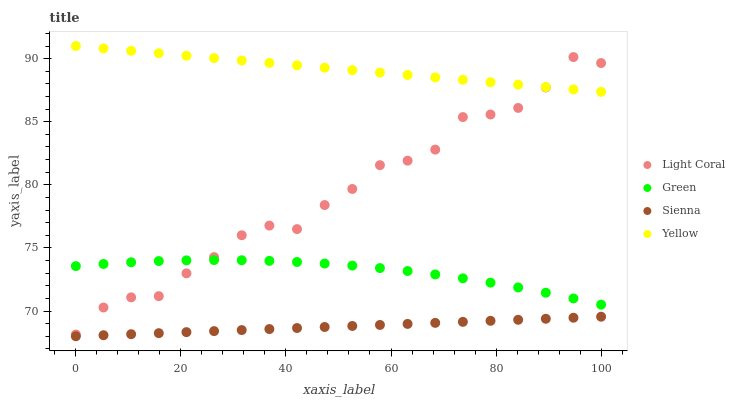Does Sienna have the minimum area under the curve?
Answer yes or no. Yes. Does Yellow have the maximum area under the curve?
Answer yes or no. Yes. Does Green have the minimum area under the curve?
Answer yes or no. No. Does Green have the maximum area under the curve?
Answer yes or no. No. Is Yellow the smoothest?
Answer yes or no. Yes. Is Light Coral the roughest?
Answer yes or no. Yes. Is Sienna the smoothest?
Answer yes or no. No. Is Sienna the roughest?
Answer yes or no. No. Does Sienna have the lowest value?
Answer yes or no. Yes. Does Green have the lowest value?
Answer yes or no. No. Does Yellow have the highest value?
Answer yes or no. Yes. Does Green have the highest value?
Answer yes or no. No. Is Sienna less than Light Coral?
Answer yes or no. Yes. Is Light Coral greater than Sienna?
Answer yes or no. Yes. Does Green intersect Light Coral?
Answer yes or no. Yes. Is Green less than Light Coral?
Answer yes or no. No. Is Green greater than Light Coral?
Answer yes or no. No. Does Sienna intersect Light Coral?
Answer yes or no. No. 